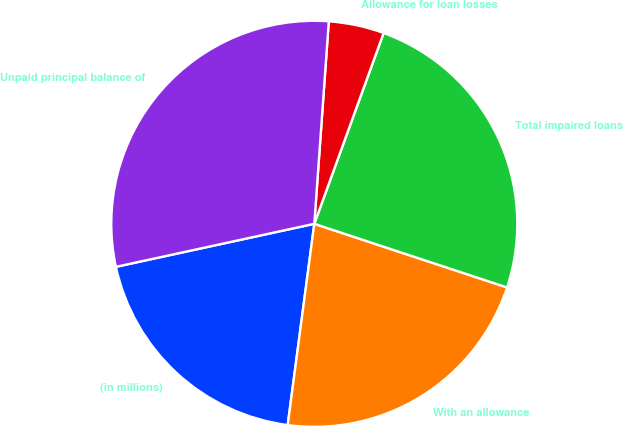Convert chart to OTSL. <chart><loc_0><loc_0><loc_500><loc_500><pie_chart><fcel>(in millions)<fcel>With an allowance<fcel>Total impaired loans<fcel>Allowance for loan losses<fcel>Unpaid principal balance of<nl><fcel>19.51%<fcel>22.02%<fcel>24.53%<fcel>4.41%<fcel>29.54%<nl></chart> 